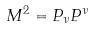Convert formula to latex. <formula><loc_0><loc_0><loc_500><loc_500>M ^ { 2 } = P _ { \nu } P ^ { \nu }</formula> 